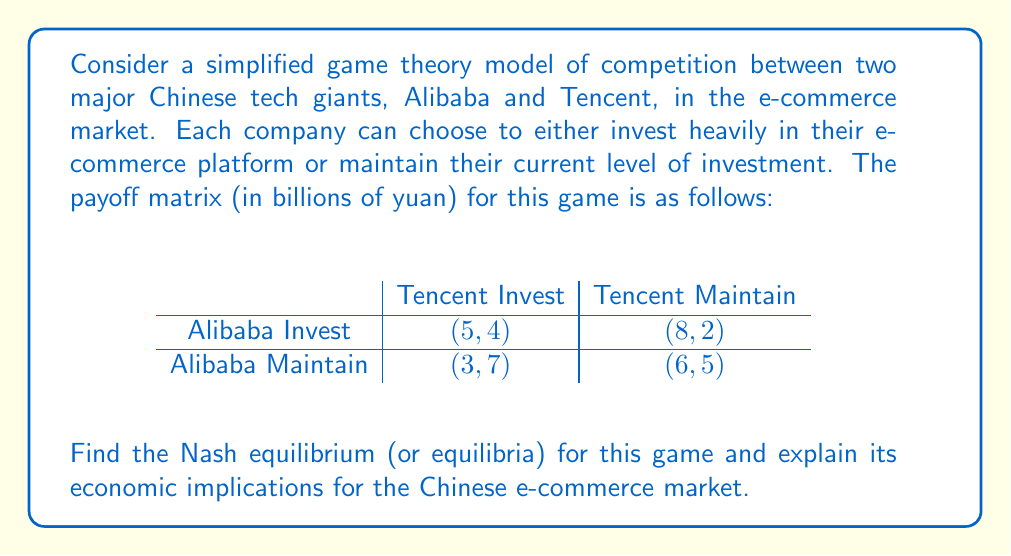Could you help me with this problem? To find the Nash equilibrium, we need to analyze each player's best response to the other player's strategy:

1. Alibaba's perspective:
   - If Tencent invests: Alibaba's payoff for investing (5) > maintaining (3)
   - If Tencent maintains: Alibaba's payoff for investing (8) > maintaining (6)

2. Tencent's perspective:
   - If Alibaba invests: Tencent's payoff for investing (4) < maintaining (2)
   - If Alibaba maintains: Tencent's payoff for investing (7) > maintaining (5)

We can see that Alibaba's dominant strategy is to invest, regardless of Tencent's choice. For Tencent, the best response depends on Alibaba's action.

Given that Alibaba will always choose to invest, Tencent's best response is to maintain its current level of investment, as 2 > 4.

Therefore, the Nash equilibrium for this game is (Alibaba Invest, Tencent Maintain), with payoffs (8, 2).

Economic implications:
1. Market leadership: The equilibrium suggests that Alibaba will likely maintain its dominant position in the Chinese e-commerce market by continuing to invest heavily.

2. Market specialization: Tencent may focus on other areas where it has a competitive advantage, such as social media and gaming, rather than directly competing with Alibaba in e-commerce.

3. Innovation and consumer benefits: Alibaba's continued investment may lead to improved e-commerce platforms and services, benefiting Chinese consumers.

4. Market concentration: This outcome could lead to a more concentrated e-commerce market in China, potentially raising concerns about monopolistic practices.

5. Resource allocation: The equilibrium reflects an efficient allocation of resources, with each company focusing on its strengths.

This simplified model provides insights into the strategic decisions of major Chinese tech companies and their potential impact on the e-commerce market structure in China.
Answer: The Nash equilibrium for this game is (Alibaba Invest, Tencent Maintain), with payoffs (8, 2) billion yuan. 